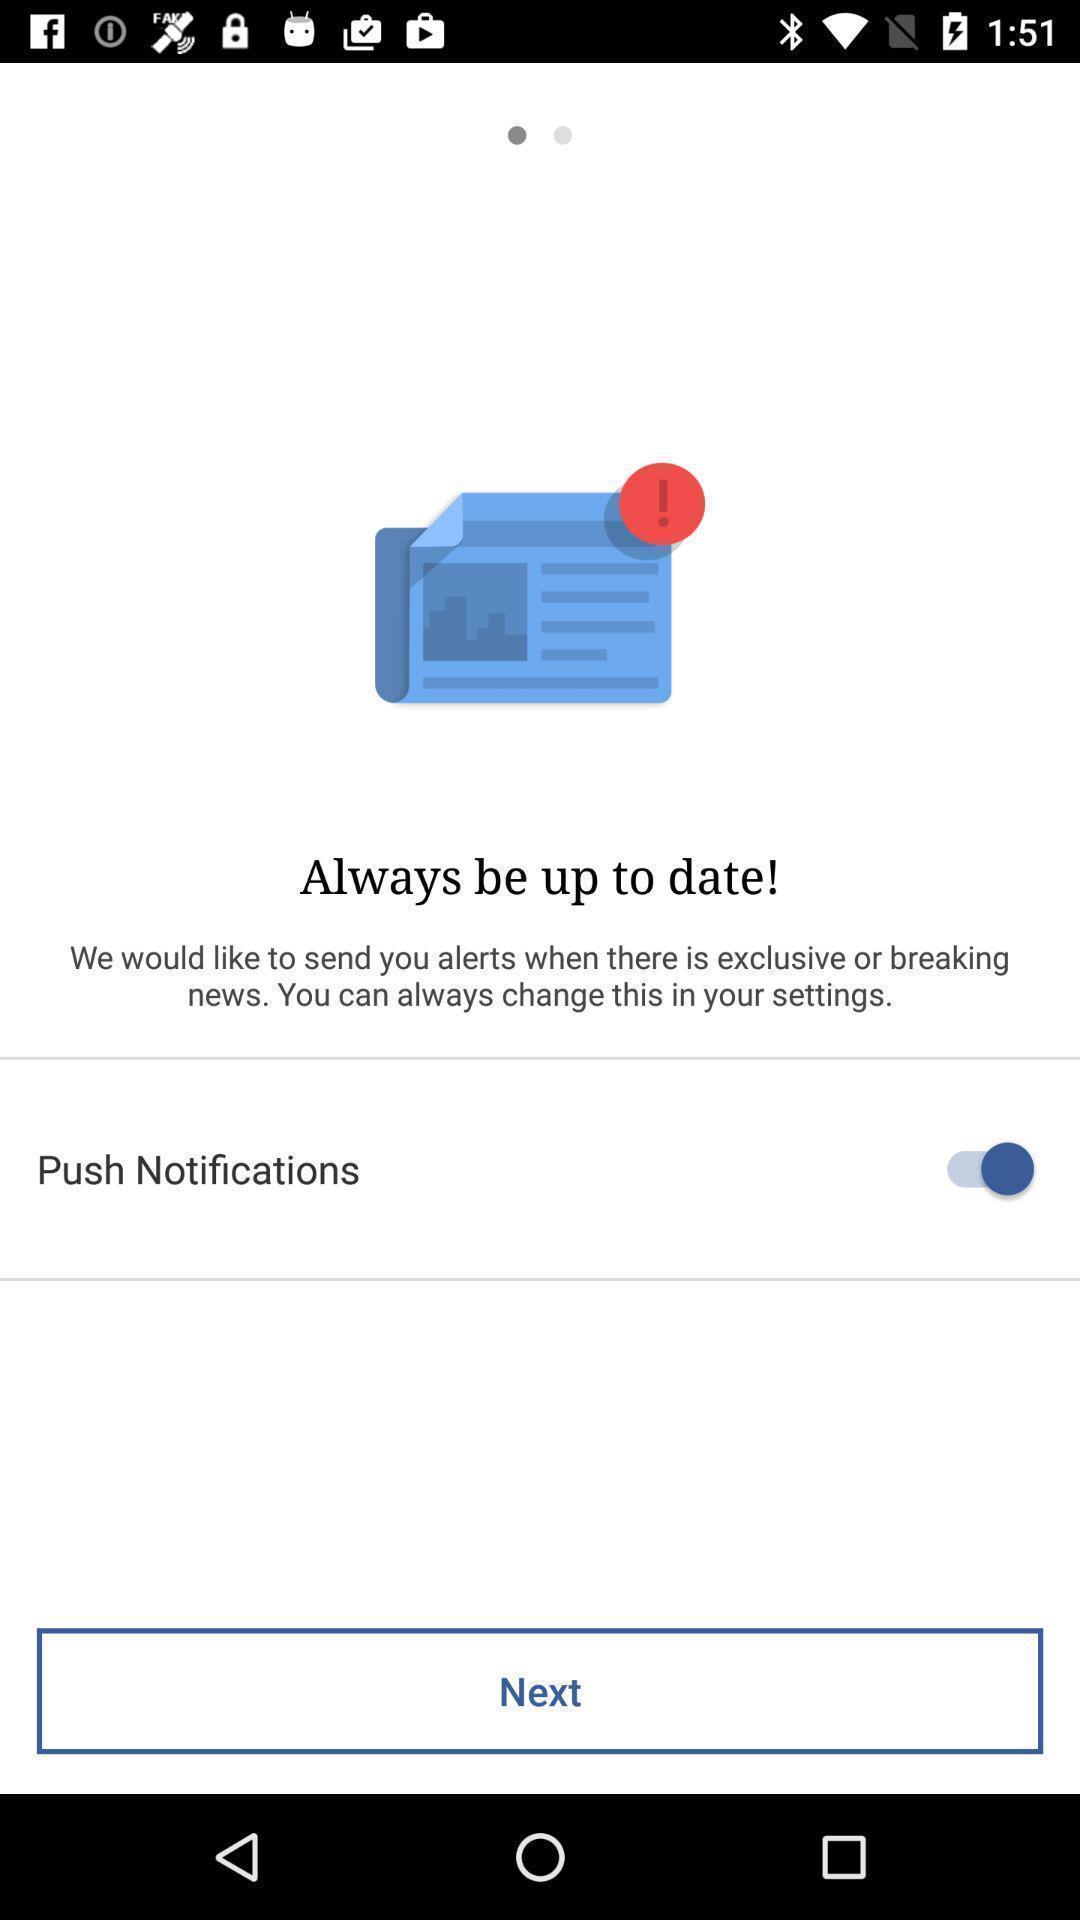Explain the elements present in this screenshot. Starting page of a news app. 